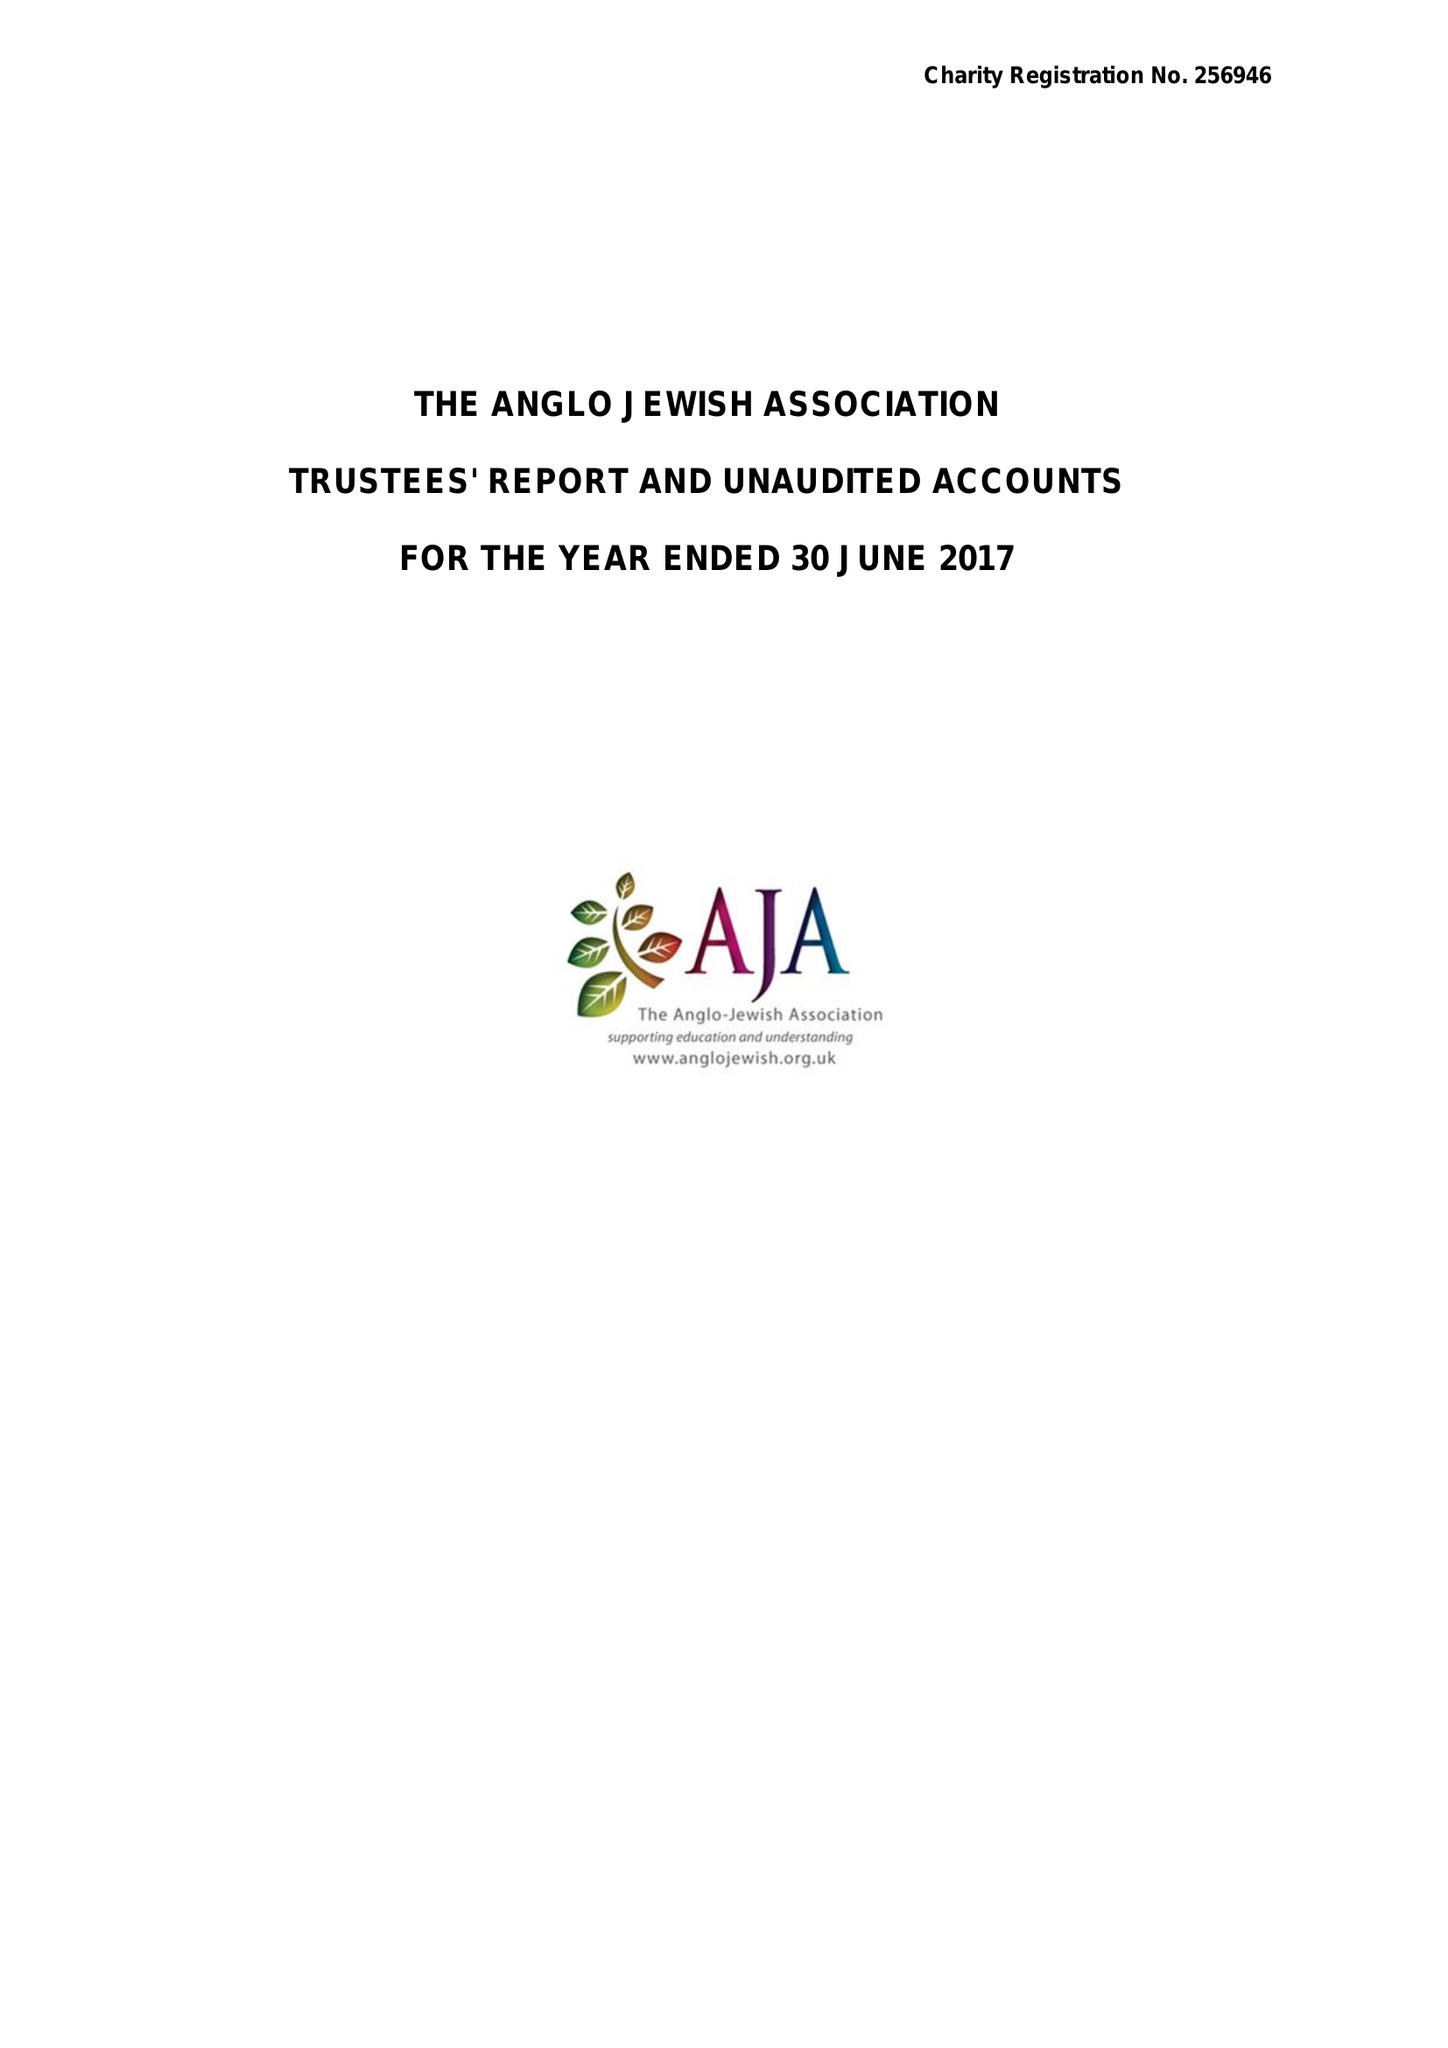What is the value for the report_date?
Answer the question using a single word or phrase. 2017-06-30 